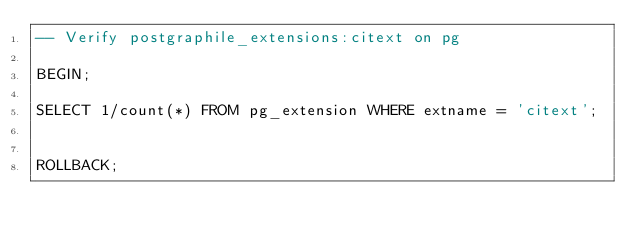Convert code to text. <code><loc_0><loc_0><loc_500><loc_500><_SQL_>-- Verify postgraphile_extensions:citext on pg

BEGIN;

SELECT 1/count(*) FROM pg_extension WHERE extname = 'citext';


ROLLBACK;
</code> 